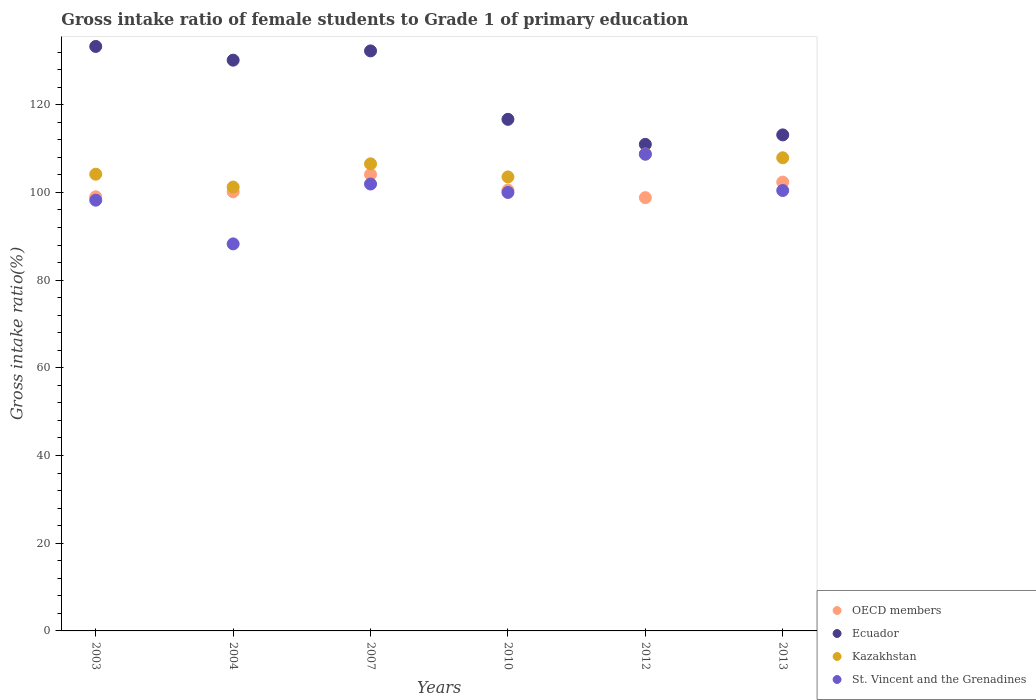How many different coloured dotlines are there?
Offer a terse response. 4. What is the gross intake ratio in OECD members in 2004?
Your answer should be compact. 100.15. Across all years, what is the maximum gross intake ratio in Kazakhstan?
Offer a very short reply. 108.77. Across all years, what is the minimum gross intake ratio in Ecuador?
Offer a very short reply. 110.97. In which year was the gross intake ratio in OECD members maximum?
Give a very brief answer. 2007. In which year was the gross intake ratio in Ecuador minimum?
Your answer should be very brief. 2012. What is the total gross intake ratio in Ecuador in the graph?
Provide a short and direct response. 736.52. What is the difference between the gross intake ratio in OECD members in 2007 and that in 2012?
Provide a short and direct response. 5.29. What is the difference between the gross intake ratio in Ecuador in 2004 and the gross intake ratio in OECD members in 2012?
Your answer should be very brief. 31.36. What is the average gross intake ratio in Ecuador per year?
Offer a very short reply. 122.75. In the year 2007, what is the difference between the gross intake ratio in OECD members and gross intake ratio in Ecuador?
Offer a very short reply. -28.18. What is the ratio of the gross intake ratio in Kazakhstan in 2007 to that in 2010?
Offer a terse response. 1.03. Is the gross intake ratio in Kazakhstan in 2010 less than that in 2013?
Keep it short and to the point. Yes. What is the difference between the highest and the second highest gross intake ratio in OECD members?
Offer a terse response. 1.74. What is the difference between the highest and the lowest gross intake ratio in Ecuador?
Provide a short and direct response. 22.33. Is the sum of the gross intake ratio in Ecuador in 2007 and 2012 greater than the maximum gross intake ratio in OECD members across all years?
Your answer should be very brief. Yes. Is it the case that in every year, the sum of the gross intake ratio in Ecuador and gross intake ratio in St. Vincent and the Grenadines  is greater than the gross intake ratio in Kazakhstan?
Your answer should be very brief. Yes. How many years are there in the graph?
Give a very brief answer. 6. What is the difference between two consecutive major ticks on the Y-axis?
Offer a very short reply. 20. Are the values on the major ticks of Y-axis written in scientific E-notation?
Make the answer very short. No. Does the graph contain grids?
Your response must be concise. No. Where does the legend appear in the graph?
Give a very brief answer. Bottom right. What is the title of the graph?
Keep it short and to the point. Gross intake ratio of female students to Grade 1 of primary education. What is the label or title of the Y-axis?
Provide a succinct answer. Gross intake ratio(%). What is the Gross intake ratio(%) of OECD members in 2003?
Ensure brevity in your answer.  99.01. What is the Gross intake ratio(%) of Ecuador in 2003?
Ensure brevity in your answer.  133.3. What is the Gross intake ratio(%) in Kazakhstan in 2003?
Give a very brief answer. 104.16. What is the Gross intake ratio(%) of St. Vincent and the Grenadines in 2003?
Provide a short and direct response. 98.24. What is the Gross intake ratio(%) of OECD members in 2004?
Ensure brevity in your answer.  100.15. What is the Gross intake ratio(%) of Ecuador in 2004?
Offer a terse response. 130.17. What is the Gross intake ratio(%) of Kazakhstan in 2004?
Offer a terse response. 101.23. What is the Gross intake ratio(%) in St. Vincent and the Grenadines in 2004?
Offer a terse response. 88.27. What is the Gross intake ratio(%) in OECD members in 2007?
Give a very brief answer. 104.1. What is the Gross intake ratio(%) of Ecuador in 2007?
Keep it short and to the point. 132.28. What is the Gross intake ratio(%) in Kazakhstan in 2007?
Keep it short and to the point. 106.53. What is the Gross intake ratio(%) of St. Vincent and the Grenadines in 2007?
Your response must be concise. 101.93. What is the Gross intake ratio(%) in OECD members in 2010?
Ensure brevity in your answer.  100.55. What is the Gross intake ratio(%) in Ecuador in 2010?
Keep it short and to the point. 116.68. What is the Gross intake ratio(%) in Kazakhstan in 2010?
Give a very brief answer. 103.54. What is the Gross intake ratio(%) in OECD members in 2012?
Provide a succinct answer. 98.81. What is the Gross intake ratio(%) in Ecuador in 2012?
Keep it short and to the point. 110.97. What is the Gross intake ratio(%) of Kazakhstan in 2012?
Your answer should be compact. 108.77. What is the Gross intake ratio(%) of St. Vincent and the Grenadines in 2012?
Keep it short and to the point. 108.72. What is the Gross intake ratio(%) in OECD members in 2013?
Offer a very short reply. 102.37. What is the Gross intake ratio(%) in Ecuador in 2013?
Your response must be concise. 113.13. What is the Gross intake ratio(%) of Kazakhstan in 2013?
Offer a very short reply. 107.91. What is the Gross intake ratio(%) in St. Vincent and the Grenadines in 2013?
Your answer should be compact. 100.45. Across all years, what is the maximum Gross intake ratio(%) of OECD members?
Your response must be concise. 104.1. Across all years, what is the maximum Gross intake ratio(%) in Ecuador?
Keep it short and to the point. 133.3. Across all years, what is the maximum Gross intake ratio(%) of Kazakhstan?
Give a very brief answer. 108.77. Across all years, what is the maximum Gross intake ratio(%) in St. Vincent and the Grenadines?
Ensure brevity in your answer.  108.72. Across all years, what is the minimum Gross intake ratio(%) of OECD members?
Your response must be concise. 98.81. Across all years, what is the minimum Gross intake ratio(%) of Ecuador?
Ensure brevity in your answer.  110.97. Across all years, what is the minimum Gross intake ratio(%) of Kazakhstan?
Your response must be concise. 101.23. Across all years, what is the minimum Gross intake ratio(%) of St. Vincent and the Grenadines?
Provide a succinct answer. 88.27. What is the total Gross intake ratio(%) in OECD members in the graph?
Provide a succinct answer. 605. What is the total Gross intake ratio(%) of Ecuador in the graph?
Provide a short and direct response. 736.52. What is the total Gross intake ratio(%) of Kazakhstan in the graph?
Ensure brevity in your answer.  632.14. What is the total Gross intake ratio(%) in St. Vincent and the Grenadines in the graph?
Provide a succinct answer. 597.6. What is the difference between the Gross intake ratio(%) of OECD members in 2003 and that in 2004?
Give a very brief answer. -1.14. What is the difference between the Gross intake ratio(%) in Ecuador in 2003 and that in 2004?
Ensure brevity in your answer.  3.13. What is the difference between the Gross intake ratio(%) in Kazakhstan in 2003 and that in 2004?
Provide a succinct answer. 2.93. What is the difference between the Gross intake ratio(%) of St. Vincent and the Grenadines in 2003 and that in 2004?
Offer a very short reply. 9.97. What is the difference between the Gross intake ratio(%) of OECD members in 2003 and that in 2007?
Your response must be concise. -5.09. What is the difference between the Gross intake ratio(%) of Ecuador in 2003 and that in 2007?
Your answer should be very brief. 1.02. What is the difference between the Gross intake ratio(%) of Kazakhstan in 2003 and that in 2007?
Your answer should be compact. -2.36. What is the difference between the Gross intake ratio(%) of St. Vincent and the Grenadines in 2003 and that in 2007?
Offer a terse response. -3.69. What is the difference between the Gross intake ratio(%) in OECD members in 2003 and that in 2010?
Offer a terse response. -1.54. What is the difference between the Gross intake ratio(%) in Ecuador in 2003 and that in 2010?
Keep it short and to the point. 16.62. What is the difference between the Gross intake ratio(%) in Kazakhstan in 2003 and that in 2010?
Ensure brevity in your answer.  0.62. What is the difference between the Gross intake ratio(%) in St. Vincent and the Grenadines in 2003 and that in 2010?
Ensure brevity in your answer.  -1.76. What is the difference between the Gross intake ratio(%) in OECD members in 2003 and that in 2012?
Give a very brief answer. 0.2. What is the difference between the Gross intake ratio(%) in Ecuador in 2003 and that in 2012?
Provide a short and direct response. 22.33. What is the difference between the Gross intake ratio(%) of Kazakhstan in 2003 and that in 2012?
Your answer should be very brief. -4.61. What is the difference between the Gross intake ratio(%) in St. Vincent and the Grenadines in 2003 and that in 2012?
Make the answer very short. -10.49. What is the difference between the Gross intake ratio(%) in OECD members in 2003 and that in 2013?
Provide a short and direct response. -3.35. What is the difference between the Gross intake ratio(%) of Ecuador in 2003 and that in 2013?
Ensure brevity in your answer.  20.17. What is the difference between the Gross intake ratio(%) in Kazakhstan in 2003 and that in 2013?
Provide a succinct answer. -3.74. What is the difference between the Gross intake ratio(%) of St. Vincent and the Grenadines in 2003 and that in 2013?
Make the answer very short. -2.21. What is the difference between the Gross intake ratio(%) in OECD members in 2004 and that in 2007?
Your answer should be very brief. -3.95. What is the difference between the Gross intake ratio(%) in Ecuador in 2004 and that in 2007?
Offer a terse response. -2.11. What is the difference between the Gross intake ratio(%) of Kazakhstan in 2004 and that in 2007?
Your answer should be very brief. -5.3. What is the difference between the Gross intake ratio(%) of St. Vincent and the Grenadines in 2004 and that in 2007?
Offer a very short reply. -13.66. What is the difference between the Gross intake ratio(%) of OECD members in 2004 and that in 2010?
Ensure brevity in your answer.  -0.4. What is the difference between the Gross intake ratio(%) of Ecuador in 2004 and that in 2010?
Provide a short and direct response. 13.5. What is the difference between the Gross intake ratio(%) of Kazakhstan in 2004 and that in 2010?
Give a very brief answer. -2.31. What is the difference between the Gross intake ratio(%) of St. Vincent and the Grenadines in 2004 and that in 2010?
Provide a short and direct response. -11.73. What is the difference between the Gross intake ratio(%) in OECD members in 2004 and that in 2012?
Your answer should be compact. 1.34. What is the difference between the Gross intake ratio(%) of Ecuador in 2004 and that in 2012?
Make the answer very short. 19.2. What is the difference between the Gross intake ratio(%) of Kazakhstan in 2004 and that in 2012?
Your answer should be very brief. -7.54. What is the difference between the Gross intake ratio(%) of St. Vincent and the Grenadines in 2004 and that in 2012?
Your answer should be compact. -20.46. What is the difference between the Gross intake ratio(%) of OECD members in 2004 and that in 2013?
Your answer should be compact. -2.21. What is the difference between the Gross intake ratio(%) of Ecuador in 2004 and that in 2013?
Your answer should be very brief. 17.04. What is the difference between the Gross intake ratio(%) in Kazakhstan in 2004 and that in 2013?
Provide a succinct answer. -6.68. What is the difference between the Gross intake ratio(%) in St. Vincent and the Grenadines in 2004 and that in 2013?
Your answer should be very brief. -12.18. What is the difference between the Gross intake ratio(%) in OECD members in 2007 and that in 2010?
Ensure brevity in your answer.  3.55. What is the difference between the Gross intake ratio(%) of Ecuador in 2007 and that in 2010?
Make the answer very short. 15.61. What is the difference between the Gross intake ratio(%) of Kazakhstan in 2007 and that in 2010?
Make the answer very short. 2.99. What is the difference between the Gross intake ratio(%) in St. Vincent and the Grenadines in 2007 and that in 2010?
Offer a terse response. 1.93. What is the difference between the Gross intake ratio(%) in OECD members in 2007 and that in 2012?
Give a very brief answer. 5.29. What is the difference between the Gross intake ratio(%) of Ecuador in 2007 and that in 2012?
Ensure brevity in your answer.  21.32. What is the difference between the Gross intake ratio(%) in Kazakhstan in 2007 and that in 2012?
Keep it short and to the point. -2.24. What is the difference between the Gross intake ratio(%) of St. Vincent and the Grenadines in 2007 and that in 2012?
Offer a terse response. -6.8. What is the difference between the Gross intake ratio(%) of OECD members in 2007 and that in 2013?
Your answer should be very brief. 1.74. What is the difference between the Gross intake ratio(%) in Ecuador in 2007 and that in 2013?
Offer a terse response. 19.15. What is the difference between the Gross intake ratio(%) of Kazakhstan in 2007 and that in 2013?
Ensure brevity in your answer.  -1.38. What is the difference between the Gross intake ratio(%) in St. Vincent and the Grenadines in 2007 and that in 2013?
Ensure brevity in your answer.  1.48. What is the difference between the Gross intake ratio(%) of OECD members in 2010 and that in 2012?
Provide a succinct answer. 1.74. What is the difference between the Gross intake ratio(%) in Ecuador in 2010 and that in 2012?
Offer a terse response. 5.71. What is the difference between the Gross intake ratio(%) in Kazakhstan in 2010 and that in 2012?
Make the answer very short. -5.23. What is the difference between the Gross intake ratio(%) of St. Vincent and the Grenadines in 2010 and that in 2012?
Give a very brief answer. -8.72. What is the difference between the Gross intake ratio(%) of OECD members in 2010 and that in 2013?
Give a very brief answer. -1.82. What is the difference between the Gross intake ratio(%) of Ecuador in 2010 and that in 2013?
Your response must be concise. 3.55. What is the difference between the Gross intake ratio(%) of Kazakhstan in 2010 and that in 2013?
Ensure brevity in your answer.  -4.37. What is the difference between the Gross intake ratio(%) of St. Vincent and the Grenadines in 2010 and that in 2013?
Your answer should be very brief. -0.45. What is the difference between the Gross intake ratio(%) in OECD members in 2012 and that in 2013?
Make the answer very short. -3.55. What is the difference between the Gross intake ratio(%) in Ecuador in 2012 and that in 2013?
Provide a short and direct response. -2.16. What is the difference between the Gross intake ratio(%) of Kazakhstan in 2012 and that in 2013?
Your response must be concise. 0.87. What is the difference between the Gross intake ratio(%) in St. Vincent and the Grenadines in 2012 and that in 2013?
Offer a very short reply. 8.28. What is the difference between the Gross intake ratio(%) in OECD members in 2003 and the Gross intake ratio(%) in Ecuador in 2004?
Offer a terse response. -31.16. What is the difference between the Gross intake ratio(%) in OECD members in 2003 and the Gross intake ratio(%) in Kazakhstan in 2004?
Ensure brevity in your answer.  -2.22. What is the difference between the Gross intake ratio(%) in OECD members in 2003 and the Gross intake ratio(%) in St. Vincent and the Grenadines in 2004?
Provide a succinct answer. 10.74. What is the difference between the Gross intake ratio(%) of Ecuador in 2003 and the Gross intake ratio(%) of Kazakhstan in 2004?
Keep it short and to the point. 32.07. What is the difference between the Gross intake ratio(%) of Ecuador in 2003 and the Gross intake ratio(%) of St. Vincent and the Grenadines in 2004?
Offer a very short reply. 45.03. What is the difference between the Gross intake ratio(%) in Kazakhstan in 2003 and the Gross intake ratio(%) in St. Vincent and the Grenadines in 2004?
Your answer should be compact. 15.9. What is the difference between the Gross intake ratio(%) of OECD members in 2003 and the Gross intake ratio(%) of Ecuador in 2007?
Offer a terse response. -33.27. What is the difference between the Gross intake ratio(%) in OECD members in 2003 and the Gross intake ratio(%) in Kazakhstan in 2007?
Ensure brevity in your answer.  -7.52. What is the difference between the Gross intake ratio(%) of OECD members in 2003 and the Gross intake ratio(%) of St. Vincent and the Grenadines in 2007?
Keep it short and to the point. -2.91. What is the difference between the Gross intake ratio(%) in Ecuador in 2003 and the Gross intake ratio(%) in Kazakhstan in 2007?
Keep it short and to the point. 26.77. What is the difference between the Gross intake ratio(%) of Ecuador in 2003 and the Gross intake ratio(%) of St. Vincent and the Grenadines in 2007?
Your answer should be compact. 31.37. What is the difference between the Gross intake ratio(%) in Kazakhstan in 2003 and the Gross intake ratio(%) in St. Vincent and the Grenadines in 2007?
Provide a succinct answer. 2.24. What is the difference between the Gross intake ratio(%) of OECD members in 2003 and the Gross intake ratio(%) of Ecuador in 2010?
Offer a terse response. -17.66. What is the difference between the Gross intake ratio(%) of OECD members in 2003 and the Gross intake ratio(%) of Kazakhstan in 2010?
Make the answer very short. -4.53. What is the difference between the Gross intake ratio(%) in OECD members in 2003 and the Gross intake ratio(%) in St. Vincent and the Grenadines in 2010?
Keep it short and to the point. -0.99. What is the difference between the Gross intake ratio(%) in Ecuador in 2003 and the Gross intake ratio(%) in Kazakhstan in 2010?
Your answer should be compact. 29.76. What is the difference between the Gross intake ratio(%) in Ecuador in 2003 and the Gross intake ratio(%) in St. Vincent and the Grenadines in 2010?
Your response must be concise. 33.3. What is the difference between the Gross intake ratio(%) in Kazakhstan in 2003 and the Gross intake ratio(%) in St. Vincent and the Grenadines in 2010?
Your answer should be very brief. 4.16. What is the difference between the Gross intake ratio(%) in OECD members in 2003 and the Gross intake ratio(%) in Ecuador in 2012?
Make the answer very short. -11.95. What is the difference between the Gross intake ratio(%) of OECD members in 2003 and the Gross intake ratio(%) of Kazakhstan in 2012?
Your answer should be compact. -9.76. What is the difference between the Gross intake ratio(%) in OECD members in 2003 and the Gross intake ratio(%) in St. Vincent and the Grenadines in 2012?
Your answer should be very brief. -9.71. What is the difference between the Gross intake ratio(%) of Ecuador in 2003 and the Gross intake ratio(%) of Kazakhstan in 2012?
Keep it short and to the point. 24.53. What is the difference between the Gross intake ratio(%) of Ecuador in 2003 and the Gross intake ratio(%) of St. Vincent and the Grenadines in 2012?
Ensure brevity in your answer.  24.57. What is the difference between the Gross intake ratio(%) in Kazakhstan in 2003 and the Gross intake ratio(%) in St. Vincent and the Grenadines in 2012?
Your answer should be compact. -4.56. What is the difference between the Gross intake ratio(%) in OECD members in 2003 and the Gross intake ratio(%) in Ecuador in 2013?
Ensure brevity in your answer.  -14.11. What is the difference between the Gross intake ratio(%) of OECD members in 2003 and the Gross intake ratio(%) of Kazakhstan in 2013?
Keep it short and to the point. -8.89. What is the difference between the Gross intake ratio(%) of OECD members in 2003 and the Gross intake ratio(%) of St. Vincent and the Grenadines in 2013?
Your answer should be very brief. -1.43. What is the difference between the Gross intake ratio(%) in Ecuador in 2003 and the Gross intake ratio(%) in Kazakhstan in 2013?
Provide a short and direct response. 25.39. What is the difference between the Gross intake ratio(%) of Ecuador in 2003 and the Gross intake ratio(%) of St. Vincent and the Grenadines in 2013?
Provide a succinct answer. 32.85. What is the difference between the Gross intake ratio(%) in Kazakhstan in 2003 and the Gross intake ratio(%) in St. Vincent and the Grenadines in 2013?
Your response must be concise. 3.72. What is the difference between the Gross intake ratio(%) of OECD members in 2004 and the Gross intake ratio(%) of Ecuador in 2007?
Offer a terse response. -32.13. What is the difference between the Gross intake ratio(%) in OECD members in 2004 and the Gross intake ratio(%) in Kazakhstan in 2007?
Offer a terse response. -6.38. What is the difference between the Gross intake ratio(%) of OECD members in 2004 and the Gross intake ratio(%) of St. Vincent and the Grenadines in 2007?
Provide a succinct answer. -1.77. What is the difference between the Gross intake ratio(%) in Ecuador in 2004 and the Gross intake ratio(%) in Kazakhstan in 2007?
Keep it short and to the point. 23.64. What is the difference between the Gross intake ratio(%) in Ecuador in 2004 and the Gross intake ratio(%) in St. Vincent and the Grenadines in 2007?
Keep it short and to the point. 28.25. What is the difference between the Gross intake ratio(%) in Kazakhstan in 2004 and the Gross intake ratio(%) in St. Vincent and the Grenadines in 2007?
Provide a short and direct response. -0.69. What is the difference between the Gross intake ratio(%) in OECD members in 2004 and the Gross intake ratio(%) in Ecuador in 2010?
Ensure brevity in your answer.  -16.52. What is the difference between the Gross intake ratio(%) in OECD members in 2004 and the Gross intake ratio(%) in Kazakhstan in 2010?
Provide a short and direct response. -3.39. What is the difference between the Gross intake ratio(%) of OECD members in 2004 and the Gross intake ratio(%) of St. Vincent and the Grenadines in 2010?
Give a very brief answer. 0.15. What is the difference between the Gross intake ratio(%) in Ecuador in 2004 and the Gross intake ratio(%) in Kazakhstan in 2010?
Offer a terse response. 26.63. What is the difference between the Gross intake ratio(%) in Ecuador in 2004 and the Gross intake ratio(%) in St. Vincent and the Grenadines in 2010?
Your answer should be compact. 30.17. What is the difference between the Gross intake ratio(%) of Kazakhstan in 2004 and the Gross intake ratio(%) of St. Vincent and the Grenadines in 2010?
Keep it short and to the point. 1.23. What is the difference between the Gross intake ratio(%) of OECD members in 2004 and the Gross intake ratio(%) of Ecuador in 2012?
Provide a succinct answer. -10.81. What is the difference between the Gross intake ratio(%) of OECD members in 2004 and the Gross intake ratio(%) of Kazakhstan in 2012?
Keep it short and to the point. -8.62. What is the difference between the Gross intake ratio(%) of OECD members in 2004 and the Gross intake ratio(%) of St. Vincent and the Grenadines in 2012?
Make the answer very short. -8.57. What is the difference between the Gross intake ratio(%) in Ecuador in 2004 and the Gross intake ratio(%) in Kazakhstan in 2012?
Give a very brief answer. 21.4. What is the difference between the Gross intake ratio(%) in Ecuador in 2004 and the Gross intake ratio(%) in St. Vincent and the Grenadines in 2012?
Keep it short and to the point. 21.45. What is the difference between the Gross intake ratio(%) of Kazakhstan in 2004 and the Gross intake ratio(%) of St. Vincent and the Grenadines in 2012?
Offer a terse response. -7.49. What is the difference between the Gross intake ratio(%) of OECD members in 2004 and the Gross intake ratio(%) of Ecuador in 2013?
Give a very brief answer. -12.98. What is the difference between the Gross intake ratio(%) in OECD members in 2004 and the Gross intake ratio(%) in Kazakhstan in 2013?
Ensure brevity in your answer.  -7.75. What is the difference between the Gross intake ratio(%) of OECD members in 2004 and the Gross intake ratio(%) of St. Vincent and the Grenadines in 2013?
Give a very brief answer. -0.29. What is the difference between the Gross intake ratio(%) of Ecuador in 2004 and the Gross intake ratio(%) of Kazakhstan in 2013?
Your answer should be very brief. 22.26. What is the difference between the Gross intake ratio(%) of Ecuador in 2004 and the Gross intake ratio(%) of St. Vincent and the Grenadines in 2013?
Provide a succinct answer. 29.73. What is the difference between the Gross intake ratio(%) of Kazakhstan in 2004 and the Gross intake ratio(%) of St. Vincent and the Grenadines in 2013?
Provide a short and direct response. 0.78. What is the difference between the Gross intake ratio(%) of OECD members in 2007 and the Gross intake ratio(%) of Ecuador in 2010?
Ensure brevity in your answer.  -12.57. What is the difference between the Gross intake ratio(%) in OECD members in 2007 and the Gross intake ratio(%) in Kazakhstan in 2010?
Keep it short and to the point. 0.56. What is the difference between the Gross intake ratio(%) of OECD members in 2007 and the Gross intake ratio(%) of St. Vincent and the Grenadines in 2010?
Make the answer very short. 4.1. What is the difference between the Gross intake ratio(%) in Ecuador in 2007 and the Gross intake ratio(%) in Kazakhstan in 2010?
Your response must be concise. 28.74. What is the difference between the Gross intake ratio(%) in Ecuador in 2007 and the Gross intake ratio(%) in St. Vincent and the Grenadines in 2010?
Your answer should be very brief. 32.28. What is the difference between the Gross intake ratio(%) in Kazakhstan in 2007 and the Gross intake ratio(%) in St. Vincent and the Grenadines in 2010?
Make the answer very short. 6.53. What is the difference between the Gross intake ratio(%) in OECD members in 2007 and the Gross intake ratio(%) in Ecuador in 2012?
Provide a short and direct response. -6.86. What is the difference between the Gross intake ratio(%) in OECD members in 2007 and the Gross intake ratio(%) in Kazakhstan in 2012?
Ensure brevity in your answer.  -4.67. What is the difference between the Gross intake ratio(%) of OECD members in 2007 and the Gross intake ratio(%) of St. Vincent and the Grenadines in 2012?
Offer a very short reply. -4.62. What is the difference between the Gross intake ratio(%) in Ecuador in 2007 and the Gross intake ratio(%) in Kazakhstan in 2012?
Provide a short and direct response. 23.51. What is the difference between the Gross intake ratio(%) of Ecuador in 2007 and the Gross intake ratio(%) of St. Vincent and the Grenadines in 2012?
Offer a terse response. 23.56. What is the difference between the Gross intake ratio(%) of Kazakhstan in 2007 and the Gross intake ratio(%) of St. Vincent and the Grenadines in 2012?
Offer a terse response. -2.2. What is the difference between the Gross intake ratio(%) of OECD members in 2007 and the Gross intake ratio(%) of Ecuador in 2013?
Your answer should be very brief. -9.02. What is the difference between the Gross intake ratio(%) of OECD members in 2007 and the Gross intake ratio(%) of Kazakhstan in 2013?
Your answer should be compact. -3.8. What is the difference between the Gross intake ratio(%) of OECD members in 2007 and the Gross intake ratio(%) of St. Vincent and the Grenadines in 2013?
Provide a succinct answer. 3.66. What is the difference between the Gross intake ratio(%) in Ecuador in 2007 and the Gross intake ratio(%) in Kazakhstan in 2013?
Ensure brevity in your answer.  24.38. What is the difference between the Gross intake ratio(%) of Ecuador in 2007 and the Gross intake ratio(%) of St. Vincent and the Grenadines in 2013?
Your answer should be very brief. 31.84. What is the difference between the Gross intake ratio(%) of Kazakhstan in 2007 and the Gross intake ratio(%) of St. Vincent and the Grenadines in 2013?
Your answer should be very brief. 6.08. What is the difference between the Gross intake ratio(%) of OECD members in 2010 and the Gross intake ratio(%) of Ecuador in 2012?
Keep it short and to the point. -10.42. What is the difference between the Gross intake ratio(%) in OECD members in 2010 and the Gross intake ratio(%) in Kazakhstan in 2012?
Offer a very short reply. -8.22. What is the difference between the Gross intake ratio(%) of OECD members in 2010 and the Gross intake ratio(%) of St. Vincent and the Grenadines in 2012?
Offer a terse response. -8.18. What is the difference between the Gross intake ratio(%) of Ecuador in 2010 and the Gross intake ratio(%) of Kazakhstan in 2012?
Your response must be concise. 7.9. What is the difference between the Gross intake ratio(%) in Ecuador in 2010 and the Gross intake ratio(%) in St. Vincent and the Grenadines in 2012?
Provide a succinct answer. 7.95. What is the difference between the Gross intake ratio(%) of Kazakhstan in 2010 and the Gross intake ratio(%) of St. Vincent and the Grenadines in 2012?
Your response must be concise. -5.18. What is the difference between the Gross intake ratio(%) of OECD members in 2010 and the Gross intake ratio(%) of Ecuador in 2013?
Provide a short and direct response. -12.58. What is the difference between the Gross intake ratio(%) in OECD members in 2010 and the Gross intake ratio(%) in Kazakhstan in 2013?
Your response must be concise. -7.36. What is the difference between the Gross intake ratio(%) in OECD members in 2010 and the Gross intake ratio(%) in St. Vincent and the Grenadines in 2013?
Make the answer very short. 0.1. What is the difference between the Gross intake ratio(%) in Ecuador in 2010 and the Gross intake ratio(%) in Kazakhstan in 2013?
Make the answer very short. 8.77. What is the difference between the Gross intake ratio(%) of Ecuador in 2010 and the Gross intake ratio(%) of St. Vincent and the Grenadines in 2013?
Offer a very short reply. 16.23. What is the difference between the Gross intake ratio(%) in Kazakhstan in 2010 and the Gross intake ratio(%) in St. Vincent and the Grenadines in 2013?
Ensure brevity in your answer.  3.09. What is the difference between the Gross intake ratio(%) in OECD members in 2012 and the Gross intake ratio(%) in Ecuador in 2013?
Your answer should be very brief. -14.32. What is the difference between the Gross intake ratio(%) of OECD members in 2012 and the Gross intake ratio(%) of Kazakhstan in 2013?
Offer a very short reply. -9.09. What is the difference between the Gross intake ratio(%) of OECD members in 2012 and the Gross intake ratio(%) of St. Vincent and the Grenadines in 2013?
Your answer should be compact. -1.63. What is the difference between the Gross intake ratio(%) in Ecuador in 2012 and the Gross intake ratio(%) in Kazakhstan in 2013?
Your answer should be very brief. 3.06. What is the difference between the Gross intake ratio(%) in Ecuador in 2012 and the Gross intake ratio(%) in St. Vincent and the Grenadines in 2013?
Your answer should be compact. 10.52. What is the difference between the Gross intake ratio(%) of Kazakhstan in 2012 and the Gross intake ratio(%) of St. Vincent and the Grenadines in 2013?
Offer a terse response. 8.33. What is the average Gross intake ratio(%) of OECD members per year?
Keep it short and to the point. 100.83. What is the average Gross intake ratio(%) in Ecuador per year?
Your answer should be very brief. 122.75. What is the average Gross intake ratio(%) of Kazakhstan per year?
Your response must be concise. 105.36. What is the average Gross intake ratio(%) in St. Vincent and the Grenadines per year?
Your answer should be very brief. 99.6. In the year 2003, what is the difference between the Gross intake ratio(%) of OECD members and Gross intake ratio(%) of Ecuador?
Your answer should be compact. -34.29. In the year 2003, what is the difference between the Gross intake ratio(%) of OECD members and Gross intake ratio(%) of Kazakhstan?
Your response must be concise. -5.15. In the year 2003, what is the difference between the Gross intake ratio(%) of OECD members and Gross intake ratio(%) of St. Vincent and the Grenadines?
Offer a very short reply. 0.78. In the year 2003, what is the difference between the Gross intake ratio(%) in Ecuador and Gross intake ratio(%) in Kazakhstan?
Your answer should be compact. 29.13. In the year 2003, what is the difference between the Gross intake ratio(%) in Ecuador and Gross intake ratio(%) in St. Vincent and the Grenadines?
Your response must be concise. 35.06. In the year 2003, what is the difference between the Gross intake ratio(%) in Kazakhstan and Gross intake ratio(%) in St. Vincent and the Grenadines?
Offer a very short reply. 5.93. In the year 2004, what is the difference between the Gross intake ratio(%) in OECD members and Gross intake ratio(%) in Ecuador?
Offer a terse response. -30.02. In the year 2004, what is the difference between the Gross intake ratio(%) of OECD members and Gross intake ratio(%) of Kazakhstan?
Provide a short and direct response. -1.08. In the year 2004, what is the difference between the Gross intake ratio(%) of OECD members and Gross intake ratio(%) of St. Vincent and the Grenadines?
Provide a succinct answer. 11.88. In the year 2004, what is the difference between the Gross intake ratio(%) of Ecuador and Gross intake ratio(%) of Kazakhstan?
Provide a short and direct response. 28.94. In the year 2004, what is the difference between the Gross intake ratio(%) in Ecuador and Gross intake ratio(%) in St. Vincent and the Grenadines?
Your answer should be compact. 41.9. In the year 2004, what is the difference between the Gross intake ratio(%) in Kazakhstan and Gross intake ratio(%) in St. Vincent and the Grenadines?
Give a very brief answer. 12.96. In the year 2007, what is the difference between the Gross intake ratio(%) in OECD members and Gross intake ratio(%) in Ecuador?
Offer a very short reply. -28.18. In the year 2007, what is the difference between the Gross intake ratio(%) in OECD members and Gross intake ratio(%) in Kazakhstan?
Your answer should be very brief. -2.43. In the year 2007, what is the difference between the Gross intake ratio(%) of OECD members and Gross intake ratio(%) of St. Vincent and the Grenadines?
Ensure brevity in your answer.  2.18. In the year 2007, what is the difference between the Gross intake ratio(%) of Ecuador and Gross intake ratio(%) of Kazakhstan?
Make the answer very short. 25.75. In the year 2007, what is the difference between the Gross intake ratio(%) in Ecuador and Gross intake ratio(%) in St. Vincent and the Grenadines?
Provide a succinct answer. 30.36. In the year 2007, what is the difference between the Gross intake ratio(%) of Kazakhstan and Gross intake ratio(%) of St. Vincent and the Grenadines?
Make the answer very short. 4.6. In the year 2010, what is the difference between the Gross intake ratio(%) of OECD members and Gross intake ratio(%) of Ecuador?
Ensure brevity in your answer.  -16.13. In the year 2010, what is the difference between the Gross intake ratio(%) of OECD members and Gross intake ratio(%) of Kazakhstan?
Offer a terse response. -2.99. In the year 2010, what is the difference between the Gross intake ratio(%) in OECD members and Gross intake ratio(%) in St. Vincent and the Grenadines?
Your response must be concise. 0.55. In the year 2010, what is the difference between the Gross intake ratio(%) in Ecuador and Gross intake ratio(%) in Kazakhstan?
Make the answer very short. 13.14. In the year 2010, what is the difference between the Gross intake ratio(%) in Ecuador and Gross intake ratio(%) in St. Vincent and the Grenadines?
Your answer should be compact. 16.68. In the year 2010, what is the difference between the Gross intake ratio(%) of Kazakhstan and Gross intake ratio(%) of St. Vincent and the Grenadines?
Make the answer very short. 3.54. In the year 2012, what is the difference between the Gross intake ratio(%) in OECD members and Gross intake ratio(%) in Ecuador?
Give a very brief answer. -12.16. In the year 2012, what is the difference between the Gross intake ratio(%) in OECD members and Gross intake ratio(%) in Kazakhstan?
Offer a very short reply. -9.96. In the year 2012, what is the difference between the Gross intake ratio(%) in OECD members and Gross intake ratio(%) in St. Vincent and the Grenadines?
Your answer should be very brief. -9.91. In the year 2012, what is the difference between the Gross intake ratio(%) in Ecuador and Gross intake ratio(%) in Kazakhstan?
Keep it short and to the point. 2.19. In the year 2012, what is the difference between the Gross intake ratio(%) in Ecuador and Gross intake ratio(%) in St. Vincent and the Grenadines?
Provide a succinct answer. 2.24. In the year 2012, what is the difference between the Gross intake ratio(%) of Kazakhstan and Gross intake ratio(%) of St. Vincent and the Grenadines?
Give a very brief answer. 0.05. In the year 2013, what is the difference between the Gross intake ratio(%) in OECD members and Gross intake ratio(%) in Ecuador?
Offer a terse response. -10.76. In the year 2013, what is the difference between the Gross intake ratio(%) in OECD members and Gross intake ratio(%) in Kazakhstan?
Your answer should be compact. -5.54. In the year 2013, what is the difference between the Gross intake ratio(%) of OECD members and Gross intake ratio(%) of St. Vincent and the Grenadines?
Your answer should be very brief. 1.92. In the year 2013, what is the difference between the Gross intake ratio(%) of Ecuador and Gross intake ratio(%) of Kazakhstan?
Your answer should be compact. 5.22. In the year 2013, what is the difference between the Gross intake ratio(%) of Ecuador and Gross intake ratio(%) of St. Vincent and the Grenadines?
Provide a succinct answer. 12.68. In the year 2013, what is the difference between the Gross intake ratio(%) of Kazakhstan and Gross intake ratio(%) of St. Vincent and the Grenadines?
Your answer should be very brief. 7.46. What is the ratio of the Gross intake ratio(%) of OECD members in 2003 to that in 2004?
Keep it short and to the point. 0.99. What is the ratio of the Gross intake ratio(%) of St. Vincent and the Grenadines in 2003 to that in 2004?
Provide a short and direct response. 1.11. What is the ratio of the Gross intake ratio(%) of OECD members in 2003 to that in 2007?
Your answer should be very brief. 0.95. What is the ratio of the Gross intake ratio(%) of Ecuador in 2003 to that in 2007?
Provide a short and direct response. 1.01. What is the ratio of the Gross intake ratio(%) in Kazakhstan in 2003 to that in 2007?
Provide a succinct answer. 0.98. What is the ratio of the Gross intake ratio(%) in St. Vincent and the Grenadines in 2003 to that in 2007?
Give a very brief answer. 0.96. What is the ratio of the Gross intake ratio(%) of OECD members in 2003 to that in 2010?
Your answer should be compact. 0.98. What is the ratio of the Gross intake ratio(%) in Ecuador in 2003 to that in 2010?
Your response must be concise. 1.14. What is the ratio of the Gross intake ratio(%) of St. Vincent and the Grenadines in 2003 to that in 2010?
Ensure brevity in your answer.  0.98. What is the ratio of the Gross intake ratio(%) of Ecuador in 2003 to that in 2012?
Offer a terse response. 1.2. What is the ratio of the Gross intake ratio(%) of Kazakhstan in 2003 to that in 2012?
Provide a short and direct response. 0.96. What is the ratio of the Gross intake ratio(%) of St. Vincent and the Grenadines in 2003 to that in 2012?
Your answer should be very brief. 0.9. What is the ratio of the Gross intake ratio(%) of OECD members in 2003 to that in 2013?
Keep it short and to the point. 0.97. What is the ratio of the Gross intake ratio(%) in Ecuador in 2003 to that in 2013?
Keep it short and to the point. 1.18. What is the ratio of the Gross intake ratio(%) of Kazakhstan in 2003 to that in 2013?
Your answer should be compact. 0.97. What is the ratio of the Gross intake ratio(%) of St. Vincent and the Grenadines in 2003 to that in 2013?
Keep it short and to the point. 0.98. What is the ratio of the Gross intake ratio(%) of Ecuador in 2004 to that in 2007?
Offer a very short reply. 0.98. What is the ratio of the Gross intake ratio(%) of Kazakhstan in 2004 to that in 2007?
Ensure brevity in your answer.  0.95. What is the ratio of the Gross intake ratio(%) of St. Vincent and the Grenadines in 2004 to that in 2007?
Your answer should be compact. 0.87. What is the ratio of the Gross intake ratio(%) in OECD members in 2004 to that in 2010?
Offer a very short reply. 1. What is the ratio of the Gross intake ratio(%) of Ecuador in 2004 to that in 2010?
Provide a succinct answer. 1.12. What is the ratio of the Gross intake ratio(%) of Kazakhstan in 2004 to that in 2010?
Your answer should be very brief. 0.98. What is the ratio of the Gross intake ratio(%) in St. Vincent and the Grenadines in 2004 to that in 2010?
Offer a terse response. 0.88. What is the ratio of the Gross intake ratio(%) of OECD members in 2004 to that in 2012?
Your response must be concise. 1.01. What is the ratio of the Gross intake ratio(%) in Ecuador in 2004 to that in 2012?
Provide a short and direct response. 1.17. What is the ratio of the Gross intake ratio(%) in Kazakhstan in 2004 to that in 2012?
Your answer should be compact. 0.93. What is the ratio of the Gross intake ratio(%) of St. Vincent and the Grenadines in 2004 to that in 2012?
Your answer should be compact. 0.81. What is the ratio of the Gross intake ratio(%) in OECD members in 2004 to that in 2013?
Provide a short and direct response. 0.98. What is the ratio of the Gross intake ratio(%) of Ecuador in 2004 to that in 2013?
Your response must be concise. 1.15. What is the ratio of the Gross intake ratio(%) in Kazakhstan in 2004 to that in 2013?
Keep it short and to the point. 0.94. What is the ratio of the Gross intake ratio(%) of St. Vincent and the Grenadines in 2004 to that in 2013?
Your answer should be very brief. 0.88. What is the ratio of the Gross intake ratio(%) of OECD members in 2007 to that in 2010?
Keep it short and to the point. 1.04. What is the ratio of the Gross intake ratio(%) of Ecuador in 2007 to that in 2010?
Keep it short and to the point. 1.13. What is the ratio of the Gross intake ratio(%) in Kazakhstan in 2007 to that in 2010?
Give a very brief answer. 1.03. What is the ratio of the Gross intake ratio(%) in St. Vincent and the Grenadines in 2007 to that in 2010?
Provide a short and direct response. 1.02. What is the ratio of the Gross intake ratio(%) of OECD members in 2007 to that in 2012?
Keep it short and to the point. 1.05. What is the ratio of the Gross intake ratio(%) of Ecuador in 2007 to that in 2012?
Give a very brief answer. 1.19. What is the ratio of the Gross intake ratio(%) in Kazakhstan in 2007 to that in 2012?
Ensure brevity in your answer.  0.98. What is the ratio of the Gross intake ratio(%) in St. Vincent and the Grenadines in 2007 to that in 2012?
Offer a very short reply. 0.94. What is the ratio of the Gross intake ratio(%) of Ecuador in 2007 to that in 2013?
Give a very brief answer. 1.17. What is the ratio of the Gross intake ratio(%) in Kazakhstan in 2007 to that in 2013?
Your answer should be very brief. 0.99. What is the ratio of the Gross intake ratio(%) of St. Vincent and the Grenadines in 2007 to that in 2013?
Give a very brief answer. 1.01. What is the ratio of the Gross intake ratio(%) of OECD members in 2010 to that in 2012?
Keep it short and to the point. 1.02. What is the ratio of the Gross intake ratio(%) of Ecuador in 2010 to that in 2012?
Your answer should be very brief. 1.05. What is the ratio of the Gross intake ratio(%) of Kazakhstan in 2010 to that in 2012?
Make the answer very short. 0.95. What is the ratio of the Gross intake ratio(%) in St. Vincent and the Grenadines in 2010 to that in 2012?
Your answer should be compact. 0.92. What is the ratio of the Gross intake ratio(%) of OECD members in 2010 to that in 2013?
Ensure brevity in your answer.  0.98. What is the ratio of the Gross intake ratio(%) in Ecuador in 2010 to that in 2013?
Your response must be concise. 1.03. What is the ratio of the Gross intake ratio(%) in Kazakhstan in 2010 to that in 2013?
Offer a very short reply. 0.96. What is the ratio of the Gross intake ratio(%) of St. Vincent and the Grenadines in 2010 to that in 2013?
Provide a succinct answer. 1. What is the ratio of the Gross intake ratio(%) of OECD members in 2012 to that in 2013?
Your answer should be compact. 0.97. What is the ratio of the Gross intake ratio(%) in Ecuador in 2012 to that in 2013?
Provide a succinct answer. 0.98. What is the ratio of the Gross intake ratio(%) of St. Vincent and the Grenadines in 2012 to that in 2013?
Your answer should be compact. 1.08. What is the difference between the highest and the second highest Gross intake ratio(%) of OECD members?
Provide a short and direct response. 1.74. What is the difference between the highest and the second highest Gross intake ratio(%) in Ecuador?
Your answer should be very brief. 1.02. What is the difference between the highest and the second highest Gross intake ratio(%) in Kazakhstan?
Offer a very short reply. 0.87. What is the difference between the highest and the second highest Gross intake ratio(%) in St. Vincent and the Grenadines?
Your answer should be very brief. 6.8. What is the difference between the highest and the lowest Gross intake ratio(%) of OECD members?
Provide a succinct answer. 5.29. What is the difference between the highest and the lowest Gross intake ratio(%) of Ecuador?
Offer a very short reply. 22.33. What is the difference between the highest and the lowest Gross intake ratio(%) in Kazakhstan?
Offer a very short reply. 7.54. What is the difference between the highest and the lowest Gross intake ratio(%) in St. Vincent and the Grenadines?
Your answer should be compact. 20.46. 